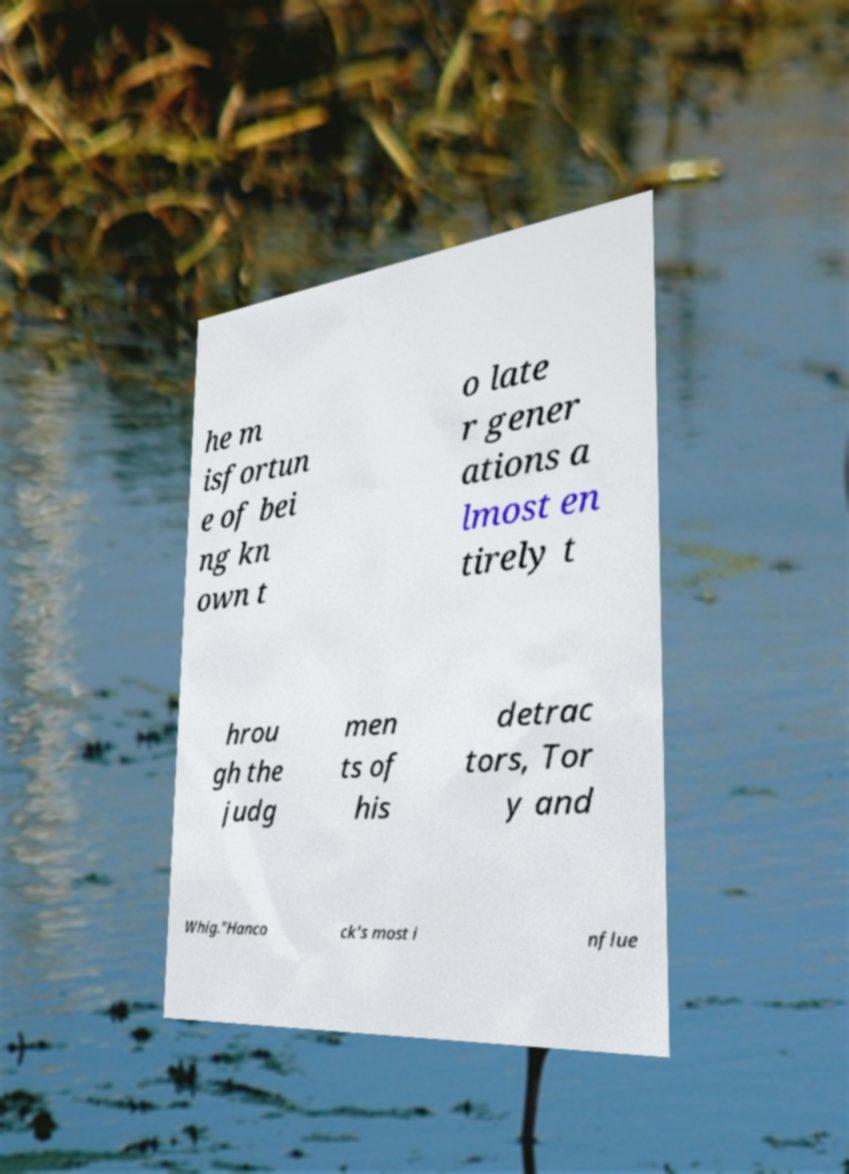Could you assist in decoding the text presented in this image and type it out clearly? he m isfortun e of bei ng kn own t o late r gener ations a lmost en tirely t hrou gh the judg men ts of his detrac tors, Tor y and Whig."Hanco ck's most i nflue 